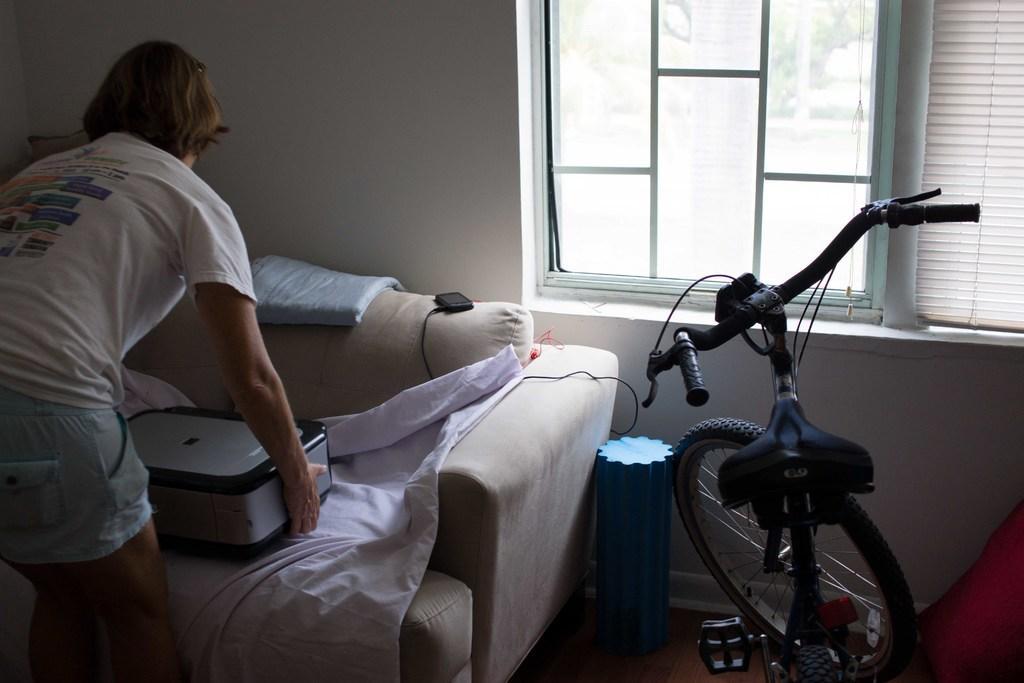Describe this image in one or two sentences. In this picture there is a person standing and holding an object in his hands in the left corner and there is a sofa in front of him and there is a bicycle in the right corner. 